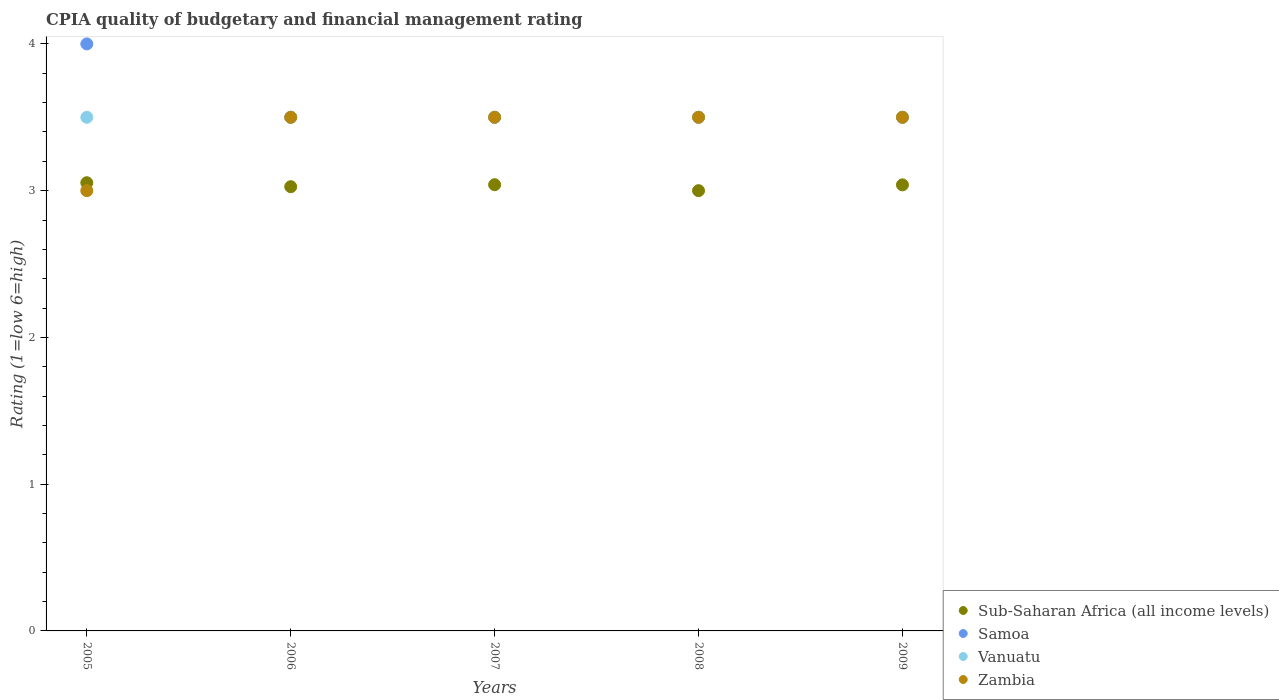How many different coloured dotlines are there?
Provide a short and direct response. 4. What is the CPIA rating in Samoa in 2006?
Provide a succinct answer. 3.5. Across all years, what is the minimum CPIA rating in Zambia?
Your answer should be very brief. 3. In which year was the CPIA rating in Vanuatu minimum?
Offer a terse response. 2005. What is the difference between the CPIA rating in Zambia in 2008 and the CPIA rating in Sub-Saharan Africa (all income levels) in 2007?
Your response must be concise. 0.46. What is the average CPIA rating in Sub-Saharan Africa (all income levels) per year?
Offer a terse response. 3.03. Is the CPIA rating in Samoa in 2005 less than that in 2008?
Ensure brevity in your answer.  No. Is the difference between the CPIA rating in Samoa in 2006 and 2008 greater than the difference between the CPIA rating in Vanuatu in 2006 and 2008?
Your answer should be compact. No. What is the difference between the highest and the second highest CPIA rating in Sub-Saharan Africa (all income levels)?
Ensure brevity in your answer.  0.01. In how many years, is the CPIA rating in Samoa greater than the average CPIA rating in Samoa taken over all years?
Your answer should be compact. 1. Is the CPIA rating in Samoa strictly greater than the CPIA rating in Vanuatu over the years?
Keep it short and to the point. No. How many dotlines are there?
Give a very brief answer. 4. Does the graph contain grids?
Keep it short and to the point. No. Where does the legend appear in the graph?
Offer a very short reply. Bottom right. How many legend labels are there?
Provide a succinct answer. 4. How are the legend labels stacked?
Make the answer very short. Vertical. What is the title of the graph?
Offer a terse response. CPIA quality of budgetary and financial management rating. Does "St. Martin (French part)" appear as one of the legend labels in the graph?
Provide a short and direct response. No. What is the label or title of the X-axis?
Keep it short and to the point. Years. What is the label or title of the Y-axis?
Ensure brevity in your answer.  Rating (1=low 6=high). What is the Rating (1=low 6=high) of Sub-Saharan Africa (all income levels) in 2005?
Give a very brief answer. 3.05. What is the Rating (1=low 6=high) of Samoa in 2005?
Make the answer very short. 4. What is the Rating (1=low 6=high) in Sub-Saharan Africa (all income levels) in 2006?
Give a very brief answer. 3.03. What is the Rating (1=low 6=high) in Samoa in 2006?
Your response must be concise. 3.5. What is the Rating (1=low 6=high) of Zambia in 2006?
Offer a terse response. 3.5. What is the Rating (1=low 6=high) of Sub-Saharan Africa (all income levels) in 2007?
Your response must be concise. 3.04. What is the Rating (1=low 6=high) of Vanuatu in 2007?
Your response must be concise. 3.5. What is the Rating (1=low 6=high) in Samoa in 2008?
Your answer should be very brief. 3.5. What is the Rating (1=low 6=high) of Sub-Saharan Africa (all income levels) in 2009?
Provide a succinct answer. 3.04. What is the Rating (1=low 6=high) of Samoa in 2009?
Your answer should be very brief. 3.5. What is the Rating (1=low 6=high) of Zambia in 2009?
Provide a short and direct response. 3.5. Across all years, what is the maximum Rating (1=low 6=high) of Sub-Saharan Africa (all income levels)?
Keep it short and to the point. 3.05. Across all years, what is the maximum Rating (1=low 6=high) of Samoa?
Make the answer very short. 4. Across all years, what is the minimum Rating (1=low 6=high) in Samoa?
Provide a succinct answer. 3.5. Across all years, what is the minimum Rating (1=low 6=high) of Vanuatu?
Provide a short and direct response. 3.5. What is the total Rating (1=low 6=high) in Sub-Saharan Africa (all income levels) in the graph?
Ensure brevity in your answer.  15.16. What is the total Rating (1=low 6=high) in Samoa in the graph?
Provide a short and direct response. 18. What is the difference between the Rating (1=low 6=high) of Sub-Saharan Africa (all income levels) in 2005 and that in 2006?
Your answer should be compact. 0.03. What is the difference between the Rating (1=low 6=high) of Zambia in 2005 and that in 2006?
Your answer should be very brief. -0.5. What is the difference between the Rating (1=low 6=high) of Sub-Saharan Africa (all income levels) in 2005 and that in 2007?
Ensure brevity in your answer.  0.01. What is the difference between the Rating (1=low 6=high) in Samoa in 2005 and that in 2007?
Your answer should be compact. 0.5. What is the difference between the Rating (1=low 6=high) of Vanuatu in 2005 and that in 2007?
Your answer should be very brief. 0. What is the difference between the Rating (1=low 6=high) of Zambia in 2005 and that in 2007?
Make the answer very short. -0.5. What is the difference between the Rating (1=low 6=high) of Sub-Saharan Africa (all income levels) in 2005 and that in 2008?
Your response must be concise. 0.05. What is the difference between the Rating (1=low 6=high) in Sub-Saharan Africa (all income levels) in 2005 and that in 2009?
Offer a very short reply. 0.01. What is the difference between the Rating (1=low 6=high) in Samoa in 2005 and that in 2009?
Offer a very short reply. 0.5. What is the difference between the Rating (1=low 6=high) in Vanuatu in 2005 and that in 2009?
Your answer should be compact. 0. What is the difference between the Rating (1=low 6=high) of Zambia in 2005 and that in 2009?
Provide a short and direct response. -0.5. What is the difference between the Rating (1=low 6=high) in Sub-Saharan Africa (all income levels) in 2006 and that in 2007?
Offer a very short reply. -0.01. What is the difference between the Rating (1=low 6=high) in Vanuatu in 2006 and that in 2007?
Provide a short and direct response. 0. What is the difference between the Rating (1=low 6=high) of Sub-Saharan Africa (all income levels) in 2006 and that in 2008?
Give a very brief answer. 0.03. What is the difference between the Rating (1=low 6=high) in Samoa in 2006 and that in 2008?
Keep it short and to the point. 0. What is the difference between the Rating (1=low 6=high) of Vanuatu in 2006 and that in 2008?
Provide a succinct answer. 0. What is the difference between the Rating (1=low 6=high) of Zambia in 2006 and that in 2008?
Your answer should be compact. 0. What is the difference between the Rating (1=low 6=high) in Sub-Saharan Africa (all income levels) in 2006 and that in 2009?
Offer a terse response. -0.01. What is the difference between the Rating (1=low 6=high) of Samoa in 2006 and that in 2009?
Your answer should be very brief. 0. What is the difference between the Rating (1=low 6=high) in Zambia in 2006 and that in 2009?
Provide a short and direct response. 0. What is the difference between the Rating (1=low 6=high) in Sub-Saharan Africa (all income levels) in 2007 and that in 2008?
Your answer should be compact. 0.04. What is the difference between the Rating (1=low 6=high) in Samoa in 2007 and that in 2008?
Your response must be concise. 0. What is the difference between the Rating (1=low 6=high) of Vanuatu in 2007 and that in 2008?
Your answer should be compact. 0. What is the difference between the Rating (1=low 6=high) in Zambia in 2007 and that in 2008?
Provide a succinct answer. 0. What is the difference between the Rating (1=low 6=high) of Sub-Saharan Africa (all income levels) in 2007 and that in 2009?
Ensure brevity in your answer.  0. What is the difference between the Rating (1=low 6=high) of Vanuatu in 2007 and that in 2009?
Your response must be concise. 0. What is the difference between the Rating (1=low 6=high) in Zambia in 2007 and that in 2009?
Give a very brief answer. 0. What is the difference between the Rating (1=low 6=high) of Sub-Saharan Africa (all income levels) in 2008 and that in 2009?
Your response must be concise. -0.04. What is the difference between the Rating (1=low 6=high) of Sub-Saharan Africa (all income levels) in 2005 and the Rating (1=low 6=high) of Samoa in 2006?
Give a very brief answer. -0.45. What is the difference between the Rating (1=low 6=high) of Sub-Saharan Africa (all income levels) in 2005 and the Rating (1=low 6=high) of Vanuatu in 2006?
Give a very brief answer. -0.45. What is the difference between the Rating (1=low 6=high) in Sub-Saharan Africa (all income levels) in 2005 and the Rating (1=low 6=high) in Zambia in 2006?
Offer a very short reply. -0.45. What is the difference between the Rating (1=low 6=high) in Samoa in 2005 and the Rating (1=low 6=high) in Vanuatu in 2006?
Provide a succinct answer. 0.5. What is the difference between the Rating (1=low 6=high) of Samoa in 2005 and the Rating (1=low 6=high) of Zambia in 2006?
Provide a short and direct response. 0.5. What is the difference between the Rating (1=low 6=high) of Vanuatu in 2005 and the Rating (1=low 6=high) of Zambia in 2006?
Your answer should be very brief. 0. What is the difference between the Rating (1=low 6=high) in Sub-Saharan Africa (all income levels) in 2005 and the Rating (1=low 6=high) in Samoa in 2007?
Provide a succinct answer. -0.45. What is the difference between the Rating (1=low 6=high) of Sub-Saharan Africa (all income levels) in 2005 and the Rating (1=low 6=high) of Vanuatu in 2007?
Your answer should be very brief. -0.45. What is the difference between the Rating (1=low 6=high) of Sub-Saharan Africa (all income levels) in 2005 and the Rating (1=low 6=high) of Zambia in 2007?
Your answer should be very brief. -0.45. What is the difference between the Rating (1=low 6=high) in Samoa in 2005 and the Rating (1=low 6=high) in Vanuatu in 2007?
Offer a very short reply. 0.5. What is the difference between the Rating (1=low 6=high) of Sub-Saharan Africa (all income levels) in 2005 and the Rating (1=low 6=high) of Samoa in 2008?
Provide a short and direct response. -0.45. What is the difference between the Rating (1=low 6=high) in Sub-Saharan Africa (all income levels) in 2005 and the Rating (1=low 6=high) in Vanuatu in 2008?
Ensure brevity in your answer.  -0.45. What is the difference between the Rating (1=low 6=high) in Sub-Saharan Africa (all income levels) in 2005 and the Rating (1=low 6=high) in Zambia in 2008?
Your answer should be compact. -0.45. What is the difference between the Rating (1=low 6=high) of Samoa in 2005 and the Rating (1=low 6=high) of Zambia in 2008?
Your response must be concise. 0.5. What is the difference between the Rating (1=low 6=high) in Sub-Saharan Africa (all income levels) in 2005 and the Rating (1=low 6=high) in Samoa in 2009?
Provide a succinct answer. -0.45. What is the difference between the Rating (1=low 6=high) in Sub-Saharan Africa (all income levels) in 2005 and the Rating (1=low 6=high) in Vanuatu in 2009?
Your response must be concise. -0.45. What is the difference between the Rating (1=low 6=high) in Sub-Saharan Africa (all income levels) in 2005 and the Rating (1=low 6=high) in Zambia in 2009?
Your response must be concise. -0.45. What is the difference between the Rating (1=low 6=high) in Samoa in 2005 and the Rating (1=low 6=high) in Vanuatu in 2009?
Offer a very short reply. 0.5. What is the difference between the Rating (1=low 6=high) of Samoa in 2005 and the Rating (1=low 6=high) of Zambia in 2009?
Offer a very short reply. 0.5. What is the difference between the Rating (1=low 6=high) in Vanuatu in 2005 and the Rating (1=low 6=high) in Zambia in 2009?
Ensure brevity in your answer.  0. What is the difference between the Rating (1=low 6=high) in Sub-Saharan Africa (all income levels) in 2006 and the Rating (1=low 6=high) in Samoa in 2007?
Offer a very short reply. -0.47. What is the difference between the Rating (1=low 6=high) in Sub-Saharan Africa (all income levels) in 2006 and the Rating (1=low 6=high) in Vanuatu in 2007?
Ensure brevity in your answer.  -0.47. What is the difference between the Rating (1=low 6=high) of Sub-Saharan Africa (all income levels) in 2006 and the Rating (1=low 6=high) of Zambia in 2007?
Provide a succinct answer. -0.47. What is the difference between the Rating (1=low 6=high) in Samoa in 2006 and the Rating (1=low 6=high) in Zambia in 2007?
Make the answer very short. 0. What is the difference between the Rating (1=low 6=high) in Sub-Saharan Africa (all income levels) in 2006 and the Rating (1=low 6=high) in Samoa in 2008?
Make the answer very short. -0.47. What is the difference between the Rating (1=low 6=high) in Sub-Saharan Africa (all income levels) in 2006 and the Rating (1=low 6=high) in Vanuatu in 2008?
Your response must be concise. -0.47. What is the difference between the Rating (1=low 6=high) of Sub-Saharan Africa (all income levels) in 2006 and the Rating (1=low 6=high) of Zambia in 2008?
Make the answer very short. -0.47. What is the difference between the Rating (1=low 6=high) of Sub-Saharan Africa (all income levels) in 2006 and the Rating (1=low 6=high) of Samoa in 2009?
Provide a succinct answer. -0.47. What is the difference between the Rating (1=low 6=high) in Sub-Saharan Africa (all income levels) in 2006 and the Rating (1=low 6=high) in Vanuatu in 2009?
Give a very brief answer. -0.47. What is the difference between the Rating (1=low 6=high) of Sub-Saharan Africa (all income levels) in 2006 and the Rating (1=low 6=high) of Zambia in 2009?
Make the answer very short. -0.47. What is the difference between the Rating (1=low 6=high) of Sub-Saharan Africa (all income levels) in 2007 and the Rating (1=low 6=high) of Samoa in 2008?
Make the answer very short. -0.46. What is the difference between the Rating (1=low 6=high) in Sub-Saharan Africa (all income levels) in 2007 and the Rating (1=low 6=high) in Vanuatu in 2008?
Offer a terse response. -0.46. What is the difference between the Rating (1=low 6=high) of Sub-Saharan Africa (all income levels) in 2007 and the Rating (1=low 6=high) of Zambia in 2008?
Your answer should be compact. -0.46. What is the difference between the Rating (1=low 6=high) in Samoa in 2007 and the Rating (1=low 6=high) in Vanuatu in 2008?
Give a very brief answer. 0. What is the difference between the Rating (1=low 6=high) of Vanuatu in 2007 and the Rating (1=low 6=high) of Zambia in 2008?
Your answer should be very brief. 0. What is the difference between the Rating (1=low 6=high) in Sub-Saharan Africa (all income levels) in 2007 and the Rating (1=low 6=high) in Samoa in 2009?
Give a very brief answer. -0.46. What is the difference between the Rating (1=low 6=high) in Sub-Saharan Africa (all income levels) in 2007 and the Rating (1=low 6=high) in Vanuatu in 2009?
Make the answer very short. -0.46. What is the difference between the Rating (1=low 6=high) in Sub-Saharan Africa (all income levels) in 2007 and the Rating (1=low 6=high) in Zambia in 2009?
Offer a very short reply. -0.46. What is the difference between the Rating (1=low 6=high) of Samoa in 2007 and the Rating (1=low 6=high) of Vanuatu in 2009?
Offer a terse response. 0. What is the difference between the Rating (1=low 6=high) of Vanuatu in 2007 and the Rating (1=low 6=high) of Zambia in 2009?
Offer a very short reply. 0. What is the difference between the Rating (1=low 6=high) of Sub-Saharan Africa (all income levels) in 2008 and the Rating (1=low 6=high) of Samoa in 2009?
Your response must be concise. -0.5. What is the difference between the Rating (1=low 6=high) in Sub-Saharan Africa (all income levels) in 2008 and the Rating (1=low 6=high) in Zambia in 2009?
Offer a very short reply. -0.5. What is the difference between the Rating (1=low 6=high) in Vanuatu in 2008 and the Rating (1=low 6=high) in Zambia in 2009?
Keep it short and to the point. 0. What is the average Rating (1=low 6=high) of Sub-Saharan Africa (all income levels) per year?
Keep it short and to the point. 3.03. What is the average Rating (1=low 6=high) in Samoa per year?
Offer a terse response. 3.6. What is the average Rating (1=low 6=high) in Vanuatu per year?
Ensure brevity in your answer.  3.5. In the year 2005, what is the difference between the Rating (1=low 6=high) of Sub-Saharan Africa (all income levels) and Rating (1=low 6=high) of Samoa?
Ensure brevity in your answer.  -0.95. In the year 2005, what is the difference between the Rating (1=low 6=high) in Sub-Saharan Africa (all income levels) and Rating (1=low 6=high) in Vanuatu?
Offer a very short reply. -0.45. In the year 2005, what is the difference between the Rating (1=low 6=high) of Sub-Saharan Africa (all income levels) and Rating (1=low 6=high) of Zambia?
Provide a short and direct response. 0.05. In the year 2005, what is the difference between the Rating (1=low 6=high) in Samoa and Rating (1=low 6=high) in Zambia?
Offer a terse response. 1. In the year 2005, what is the difference between the Rating (1=low 6=high) of Vanuatu and Rating (1=low 6=high) of Zambia?
Keep it short and to the point. 0.5. In the year 2006, what is the difference between the Rating (1=low 6=high) in Sub-Saharan Africa (all income levels) and Rating (1=low 6=high) in Samoa?
Provide a succinct answer. -0.47. In the year 2006, what is the difference between the Rating (1=low 6=high) of Sub-Saharan Africa (all income levels) and Rating (1=low 6=high) of Vanuatu?
Keep it short and to the point. -0.47. In the year 2006, what is the difference between the Rating (1=low 6=high) of Sub-Saharan Africa (all income levels) and Rating (1=low 6=high) of Zambia?
Your answer should be compact. -0.47. In the year 2006, what is the difference between the Rating (1=low 6=high) of Samoa and Rating (1=low 6=high) of Zambia?
Offer a very short reply. 0. In the year 2006, what is the difference between the Rating (1=low 6=high) in Vanuatu and Rating (1=low 6=high) in Zambia?
Provide a short and direct response. 0. In the year 2007, what is the difference between the Rating (1=low 6=high) in Sub-Saharan Africa (all income levels) and Rating (1=low 6=high) in Samoa?
Offer a terse response. -0.46. In the year 2007, what is the difference between the Rating (1=low 6=high) of Sub-Saharan Africa (all income levels) and Rating (1=low 6=high) of Vanuatu?
Make the answer very short. -0.46. In the year 2007, what is the difference between the Rating (1=low 6=high) of Sub-Saharan Africa (all income levels) and Rating (1=low 6=high) of Zambia?
Keep it short and to the point. -0.46. In the year 2007, what is the difference between the Rating (1=low 6=high) in Samoa and Rating (1=low 6=high) in Zambia?
Your response must be concise. 0. In the year 2008, what is the difference between the Rating (1=low 6=high) of Sub-Saharan Africa (all income levels) and Rating (1=low 6=high) of Zambia?
Ensure brevity in your answer.  -0.5. In the year 2008, what is the difference between the Rating (1=low 6=high) of Samoa and Rating (1=low 6=high) of Vanuatu?
Your answer should be compact. 0. In the year 2008, what is the difference between the Rating (1=low 6=high) in Samoa and Rating (1=low 6=high) in Zambia?
Give a very brief answer. 0. In the year 2008, what is the difference between the Rating (1=low 6=high) in Vanuatu and Rating (1=low 6=high) in Zambia?
Your answer should be compact. 0. In the year 2009, what is the difference between the Rating (1=low 6=high) of Sub-Saharan Africa (all income levels) and Rating (1=low 6=high) of Samoa?
Your answer should be very brief. -0.46. In the year 2009, what is the difference between the Rating (1=low 6=high) of Sub-Saharan Africa (all income levels) and Rating (1=low 6=high) of Vanuatu?
Your answer should be compact. -0.46. In the year 2009, what is the difference between the Rating (1=low 6=high) of Sub-Saharan Africa (all income levels) and Rating (1=low 6=high) of Zambia?
Offer a terse response. -0.46. In the year 2009, what is the difference between the Rating (1=low 6=high) in Samoa and Rating (1=low 6=high) in Vanuatu?
Ensure brevity in your answer.  0. In the year 2009, what is the difference between the Rating (1=low 6=high) in Vanuatu and Rating (1=low 6=high) in Zambia?
Ensure brevity in your answer.  0. What is the ratio of the Rating (1=low 6=high) in Sub-Saharan Africa (all income levels) in 2005 to that in 2006?
Your answer should be very brief. 1.01. What is the ratio of the Rating (1=low 6=high) in Zambia in 2005 to that in 2006?
Keep it short and to the point. 0.86. What is the ratio of the Rating (1=low 6=high) in Samoa in 2005 to that in 2007?
Provide a succinct answer. 1.14. What is the ratio of the Rating (1=low 6=high) of Zambia in 2005 to that in 2007?
Your answer should be very brief. 0.86. What is the ratio of the Rating (1=low 6=high) of Sub-Saharan Africa (all income levels) in 2005 to that in 2008?
Keep it short and to the point. 1.02. What is the ratio of the Rating (1=low 6=high) of Samoa in 2006 to that in 2007?
Offer a terse response. 1. What is the ratio of the Rating (1=low 6=high) in Zambia in 2006 to that in 2007?
Your response must be concise. 1. What is the ratio of the Rating (1=low 6=high) in Samoa in 2006 to that in 2008?
Keep it short and to the point. 1. What is the ratio of the Rating (1=low 6=high) of Vanuatu in 2006 to that in 2008?
Your answer should be very brief. 1. What is the ratio of the Rating (1=low 6=high) in Zambia in 2006 to that in 2008?
Ensure brevity in your answer.  1. What is the ratio of the Rating (1=low 6=high) in Sub-Saharan Africa (all income levels) in 2006 to that in 2009?
Your answer should be compact. 1. What is the ratio of the Rating (1=low 6=high) in Vanuatu in 2006 to that in 2009?
Your answer should be compact. 1. What is the ratio of the Rating (1=low 6=high) in Zambia in 2006 to that in 2009?
Offer a very short reply. 1. What is the ratio of the Rating (1=low 6=high) of Sub-Saharan Africa (all income levels) in 2007 to that in 2008?
Offer a terse response. 1.01. What is the ratio of the Rating (1=low 6=high) in Sub-Saharan Africa (all income levels) in 2008 to that in 2009?
Provide a succinct answer. 0.99. What is the ratio of the Rating (1=low 6=high) in Samoa in 2008 to that in 2009?
Provide a succinct answer. 1. What is the difference between the highest and the second highest Rating (1=low 6=high) in Sub-Saharan Africa (all income levels)?
Your answer should be compact. 0.01. What is the difference between the highest and the second highest Rating (1=low 6=high) in Zambia?
Your answer should be compact. 0. What is the difference between the highest and the lowest Rating (1=low 6=high) in Sub-Saharan Africa (all income levels)?
Offer a terse response. 0.05. What is the difference between the highest and the lowest Rating (1=low 6=high) in Samoa?
Your answer should be compact. 0.5. What is the difference between the highest and the lowest Rating (1=low 6=high) in Vanuatu?
Keep it short and to the point. 0. What is the difference between the highest and the lowest Rating (1=low 6=high) in Zambia?
Ensure brevity in your answer.  0.5. 